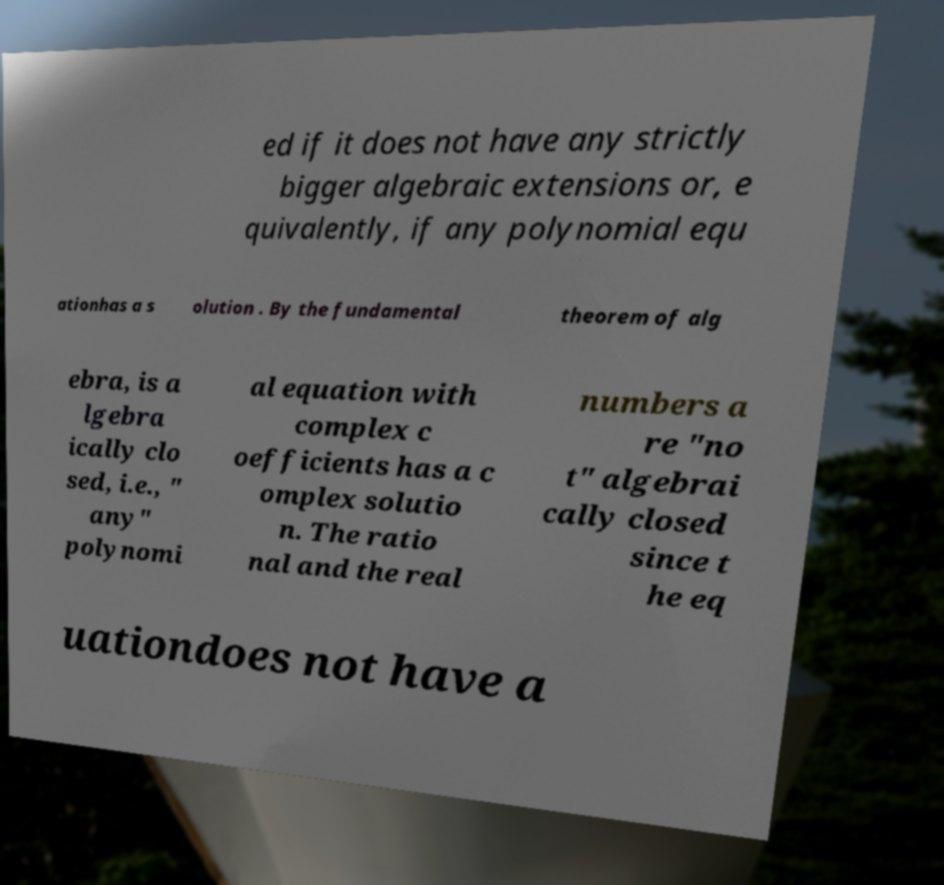There's text embedded in this image that I need extracted. Can you transcribe it verbatim? ed if it does not have any strictly bigger algebraic extensions or, e quivalently, if any polynomial equ ationhas a s olution . By the fundamental theorem of alg ebra, is a lgebra ically clo sed, i.e., " any" polynomi al equation with complex c oefficients has a c omplex solutio n. The ratio nal and the real numbers a re "no t" algebrai cally closed since t he eq uationdoes not have a 